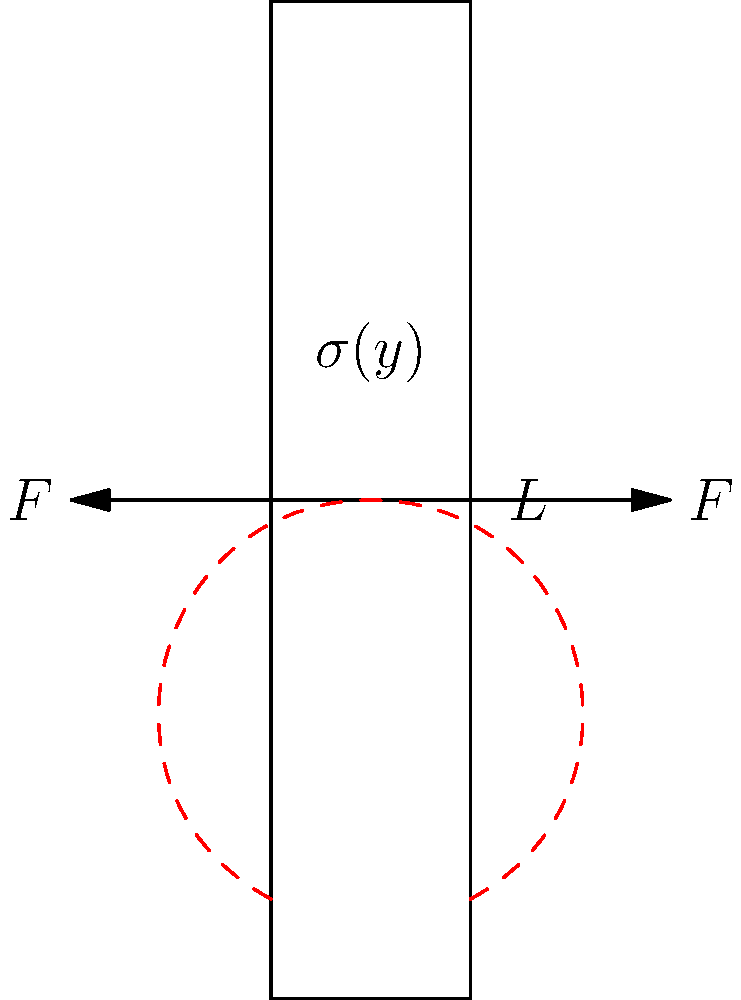Consider a book binding under stress as shown in the force diagram. The spine of the book has a length $L$ and is subjected to equal and opposite forces $F$ at its midpoint. Assuming the spine behaves as a thin beam, derive an expression for the maximum bending stress $\sigma_{max}$ in terms of $F$, $L$, and the moment of inertia $I$ of the spine's cross-section. To solve this problem, we'll follow these steps:

1) First, recognize that this scenario represents a simple beam bending problem.

2) The maximum bending moment $M_{max}$ occurs at the center of the spine where the forces are applied. It can be calculated as:

   $$M_{max} = \frac{FL}{4}$$

3) The general equation for bending stress in a beam is:

   $$\sigma = \frac{My}{I}$$

   where $M$ is the bending moment, $y$ is the distance from the neutral axis, and $I$ is the moment of inertia of the cross-section.

4) The maximum stress occurs at the outer fibers of the beam, where $y$ is maximum. Let's call the half-thickness of the spine $c$. Then:

   $$\sigma_{max} = \frac{M_{max}c}{I}$$

5) Substituting the expression for $M_{max}$ from step 2:

   $$\sigma_{max} = \frac{FLc}{4I}$$

This is the final expression for the maximum bending stress in the book spine.
Answer: $\sigma_{max} = \frac{FLc}{4I}$ 